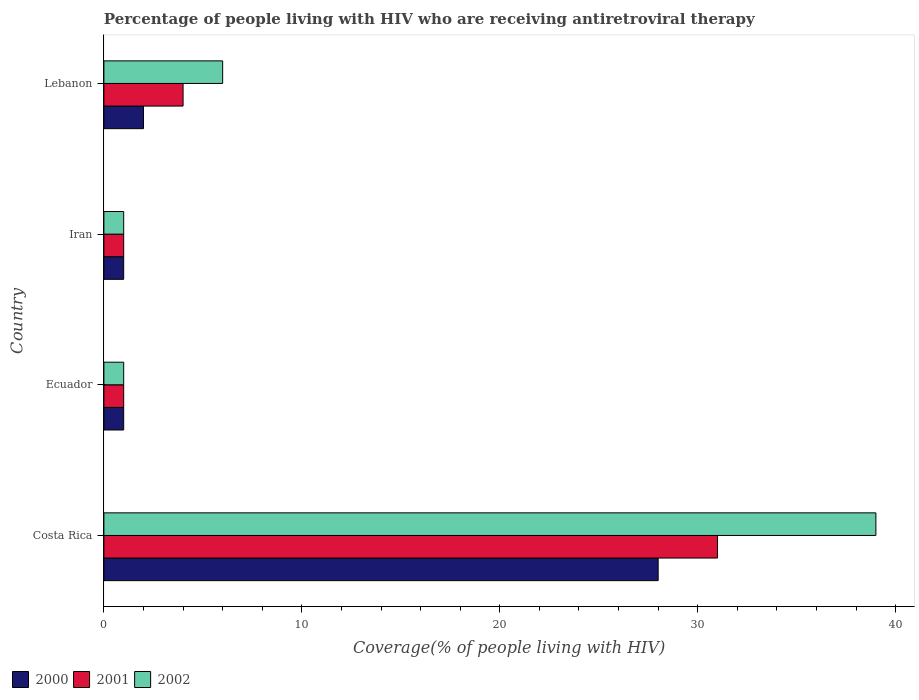How many groups of bars are there?
Keep it short and to the point. 4. Are the number of bars on each tick of the Y-axis equal?
Your answer should be compact. Yes. How many bars are there on the 2nd tick from the top?
Give a very brief answer. 3. What is the label of the 3rd group of bars from the top?
Give a very brief answer. Ecuador. What is the percentage of the HIV infected people who are receiving antiretroviral therapy in 2000 in Lebanon?
Your answer should be compact. 2. Across all countries, what is the minimum percentage of the HIV infected people who are receiving antiretroviral therapy in 2002?
Keep it short and to the point. 1. In which country was the percentage of the HIV infected people who are receiving antiretroviral therapy in 2002 maximum?
Give a very brief answer. Costa Rica. In which country was the percentage of the HIV infected people who are receiving antiretroviral therapy in 2002 minimum?
Provide a succinct answer. Ecuador. What is the total percentage of the HIV infected people who are receiving antiretroviral therapy in 2000 in the graph?
Your answer should be very brief. 32. What is the average percentage of the HIV infected people who are receiving antiretroviral therapy in 2000 per country?
Your answer should be compact. 8. What is the ratio of the percentage of the HIV infected people who are receiving antiretroviral therapy in 2002 in Costa Rica to that in Lebanon?
Your answer should be compact. 6.5. Is the difference between the percentage of the HIV infected people who are receiving antiretroviral therapy in 2001 in Costa Rica and Iran greater than the difference between the percentage of the HIV infected people who are receiving antiretroviral therapy in 2000 in Costa Rica and Iran?
Offer a terse response. Yes. In how many countries, is the percentage of the HIV infected people who are receiving antiretroviral therapy in 2002 greater than the average percentage of the HIV infected people who are receiving antiretroviral therapy in 2002 taken over all countries?
Provide a succinct answer. 1. What does the 1st bar from the top in Iran represents?
Your answer should be very brief. 2002. What does the 1st bar from the bottom in Ecuador represents?
Offer a very short reply. 2000. Is it the case that in every country, the sum of the percentage of the HIV infected people who are receiving antiretroviral therapy in 2000 and percentage of the HIV infected people who are receiving antiretroviral therapy in 2001 is greater than the percentage of the HIV infected people who are receiving antiretroviral therapy in 2002?
Your answer should be very brief. No. How many countries are there in the graph?
Make the answer very short. 4. Are the values on the major ticks of X-axis written in scientific E-notation?
Your answer should be very brief. No. Does the graph contain grids?
Offer a terse response. No. Where does the legend appear in the graph?
Your answer should be compact. Bottom left. How are the legend labels stacked?
Your response must be concise. Horizontal. What is the title of the graph?
Your answer should be very brief. Percentage of people living with HIV who are receiving antiretroviral therapy. What is the label or title of the X-axis?
Your answer should be compact. Coverage(% of people living with HIV). What is the Coverage(% of people living with HIV) of 2000 in Costa Rica?
Provide a short and direct response. 28. What is the Coverage(% of people living with HIV) in 2000 in Ecuador?
Offer a terse response. 1. What is the Coverage(% of people living with HIV) of 2001 in Iran?
Offer a terse response. 1. What is the Coverage(% of people living with HIV) of 2001 in Lebanon?
Your answer should be compact. 4. What is the Coverage(% of people living with HIV) of 2002 in Lebanon?
Your response must be concise. 6. Across all countries, what is the maximum Coverage(% of people living with HIV) in 2001?
Make the answer very short. 31. Across all countries, what is the maximum Coverage(% of people living with HIV) of 2002?
Offer a terse response. 39. Across all countries, what is the minimum Coverage(% of people living with HIV) in 2002?
Your answer should be compact. 1. What is the total Coverage(% of people living with HIV) of 2000 in the graph?
Offer a terse response. 32. What is the total Coverage(% of people living with HIV) of 2001 in the graph?
Make the answer very short. 37. What is the difference between the Coverage(% of people living with HIV) in 2000 in Costa Rica and that in Ecuador?
Make the answer very short. 27. What is the difference between the Coverage(% of people living with HIV) of 2002 in Costa Rica and that in Ecuador?
Your answer should be very brief. 38. What is the difference between the Coverage(% of people living with HIV) of 2000 in Costa Rica and that in Iran?
Keep it short and to the point. 27. What is the difference between the Coverage(% of people living with HIV) of 2001 in Costa Rica and that in Iran?
Your answer should be very brief. 30. What is the difference between the Coverage(% of people living with HIV) of 2000 in Costa Rica and that in Lebanon?
Keep it short and to the point. 26. What is the difference between the Coverage(% of people living with HIV) in 2001 in Costa Rica and that in Lebanon?
Provide a succinct answer. 27. What is the difference between the Coverage(% of people living with HIV) in 2000 in Ecuador and that in Iran?
Your answer should be compact. 0. What is the difference between the Coverage(% of people living with HIV) of 2000 in Ecuador and that in Lebanon?
Your answer should be very brief. -1. What is the difference between the Coverage(% of people living with HIV) in 2000 in Iran and that in Lebanon?
Keep it short and to the point. -1. What is the difference between the Coverage(% of people living with HIV) of 2001 in Iran and that in Lebanon?
Keep it short and to the point. -3. What is the difference between the Coverage(% of people living with HIV) in 2000 in Costa Rica and the Coverage(% of people living with HIV) in 2001 in Ecuador?
Provide a succinct answer. 27. What is the difference between the Coverage(% of people living with HIV) of 2000 in Costa Rica and the Coverage(% of people living with HIV) of 2002 in Ecuador?
Give a very brief answer. 27. What is the difference between the Coverage(% of people living with HIV) of 2000 in Costa Rica and the Coverage(% of people living with HIV) of 2002 in Iran?
Provide a short and direct response. 27. What is the difference between the Coverage(% of people living with HIV) in 2001 in Costa Rica and the Coverage(% of people living with HIV) in 2002 in Iran?
Your answer should be compact. 30. What is the difference between the Coverage(% of people living with HIV) of 2000 in Costa Rica and the Coverage(% of people living with HIV) of 2001 in Lebanon?
Your response must be concise. 24. What is the difference between the Coverage(% of people living with HIV) of 2001 in Costa Rica and the Coverage(% of people living with HIV) of 2002 in Lebanon?
Ensure brevity in your answer.  25. What is the difference between the Coverage(% of people living with HIV) in 2000 in Ecuador and the Coverage(% of people living with HIV) in 2001 in Iran?
Give a very brief answer. 0. What is the difference between the Coverage(% of people living with HIV) of 2000 in Ecuador and the Coverage(% of people living with HIV) of 2001 in Lebanon?
Keep it short and to the point. -3. What is the difference between the Coverage(% of people living with HIV) of 2000 in Ecuador and the Coverage(% of people living with HIV) of 2002 in Lebanon?
Your answer should be compact. -5. What is the difference between the Coverage(% of people living with HIV) in 2000 in Iran and the Coverage(% of people living with HIV) in 2001 in Lebanon?
Provide a succinct answer. -3. What is the difference between the Coverage(% of people living with HIV) of 2000 in Iran and the Coverage(% of people living with HIV) of 2002 in Lebanon?
Offer a very short reply. -5. What is the average Coverage(% of people living with HIV) of 2001 per country?
Keep it short and to the point. 9.25. What is the average Coverage(% of people living with HIV) in 2002 per country?
Give a very brief answer. 11.75. What is the difference between the Coverage(% of people living with HIV) of 2000 and Coverage(% of people living with HIV) of 2002 in Costa Rica?
Your answer should be very brief. -11. What is the difference between the Coverage(% of people living with HIV) in 2001 and Coverage(% of people living with HIV) in 2002 in Costa Rica?
Offer a terse response. -8. What is the difference between the Coverage(% of people living with HIV) of 2000 and Coverage(% of people living with HIV) of 2001 in Ecuador?
Give a very brief answer. 0. What is the difference between the Coverage(% of people living with HIV) of 2000 and Coverage(% of people living with HIV) of 2002 in Ecuador?
Your response must be concise. 0. What is the difference between the Coverage(% of people living with HIV) in 2001 and Coverage(% of people living with HIV) in 2002 in Ecuador?
Your response must be concise. 0. What is the difference between the Coverage(% of people living with HIV) of 2001 and Coverage(% of people living with HIV) of 2002 in Iran?
Your response must be concise. 0. What is the difference between the Coverage(% of people living with HIV) in 2000 and Coverage(% of people living with HIV) in 2002 in Lebanon?
Ensure brevity in your answer.  -4. What is the ratio of the Coverage(% of people living with HIV) of 2001 in Costa Rica to that in Ecuador?
Your answer should be very brief. 31. What is the ratio of the Coverage(% of people living with HIV) of 2000 in Costa Rica to that in Iran?
Provide a succinct answer. 28. What is the ratio of the Coverage(% of people living with HIV) in 2000 in Costa Rica to that in Lebanon?
Offer a terse response. 14. What is the ratio of the Coverage(% of people living with HIV) of 2001 in Costa Rica to that in Lebanon?
Offer a terse response. 7.75. What is the ratio of the Coverage(% of people living with HIV) of 2000 in Ecuador to that in Lebanon?
Make the answer very short. 0.5. What is the ratio of the Coverage(% of people living with HIV) in 2000 in Iran to that in Lebanon?
Offer a very short reply. 0.5. What is the ratio of the Coverage(% of people living with HIV) of 2001 in Iran to that in Lebanon?
Provide a succinct answer. 0.25. What is the ratio of the Coverage(% of people living with HIV) of 2002 in Iran to that in Lebanon?
Ensure brevity in your answer.  0.17. What is the difference between the highest and the second highest Coverage(% of people living with HIV) of 2000?
Provide a short and direct response. 26. What is the difference between the highest and the second highest Coverage(% of people living with HIV) in 2002?
Provide a succinct answer. 33. What is the difference between the highest and the lowest Coverage(% of people living with HIV) in 2000?
Provide a succinct answer. 27. What is the difference between the highest and the lowest Coverage(% of people living with HIV) of 2001?
Your answer should be compact. 30. 